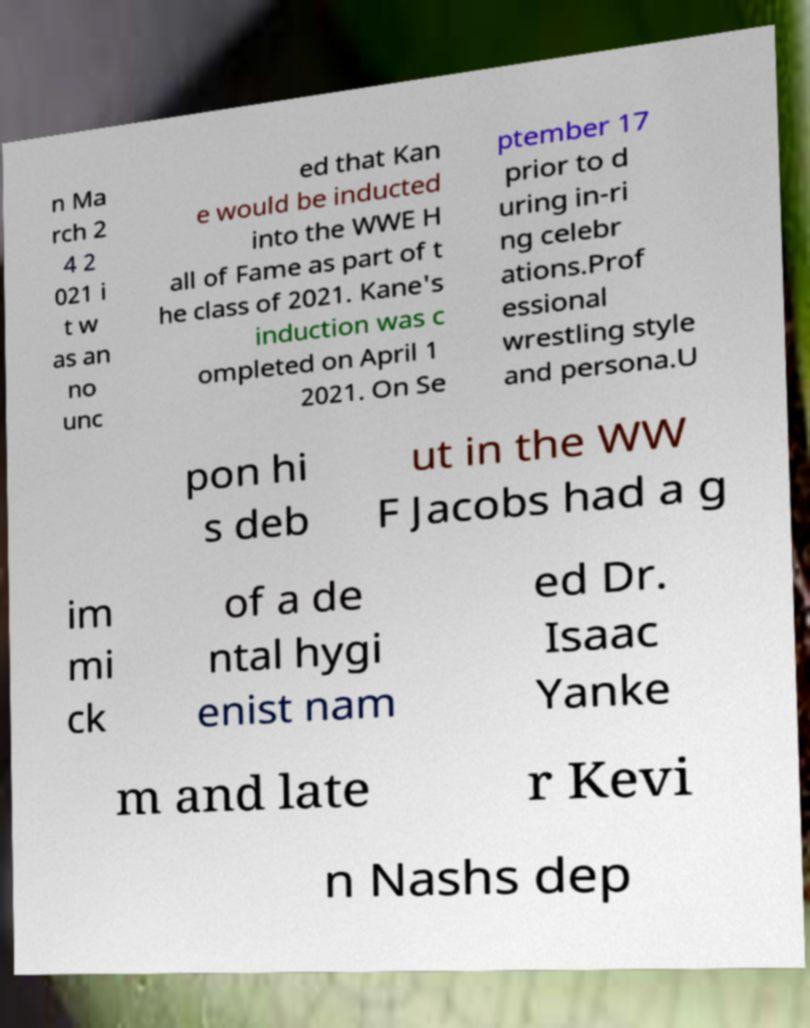What messages or text are displayed in this image? I need them in a readable, typed format. n Ma rch 2 4 2 021 i t w as an no unc ed that Kan e would be inducted into the WWE H all of Fame as part of t he class of 2021. Kane's induction was c ompleted on April 1 2021. On Se ptember 17 prior to d uring in-ri ng celebr ations.Prof essional wrestling style and persona.U pon hi s deb ut in the WW F Jacobs had a g im mi ck of a de ntal hygi enist nam ed Dr. Isaac Yanke m and late r Kevi n Nashs dep 